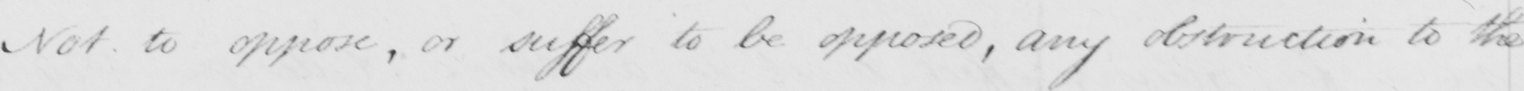Transcribe the text shown in this historical manuscript line. Not to oppose, or suffer to be opposed, any obstruction to the 